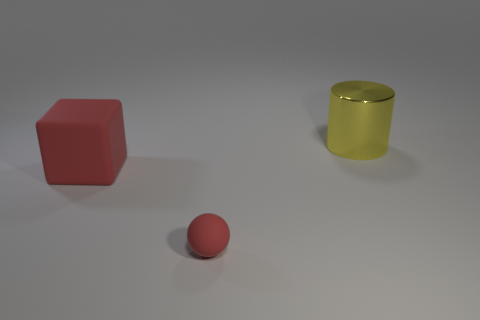Are there any other things that are the same size as the ball?
Offer a terse response. No. Is there anything else that is the same material as the cube?
Offer a terse response. Yes. There is a large metal thing; what shape is it?
Your response must be concise. Cylinder. The matte thing that is the same size as the yellow metal object is what shape?
Offer a very short reply. Cube. Is there any other thing that has the same color as the metal cylinder?
Provide a succinct answer. No. There is a block that is made of the same material as the sphere; what is its size?
Your response must be concise. Large. Do the tiny red thing and the big thing that is left of the big yellow cylinder have the same shape?
Offer a very short reply. No. The cylinder has what size?
Your response must be concise. Large. Are there fewer red things that are right of the big matte cube than green rubber cylinders?
Offer a terse response. No. How many rubber cubes are the same size as the red sphere?
Your response must be concise. 0. 